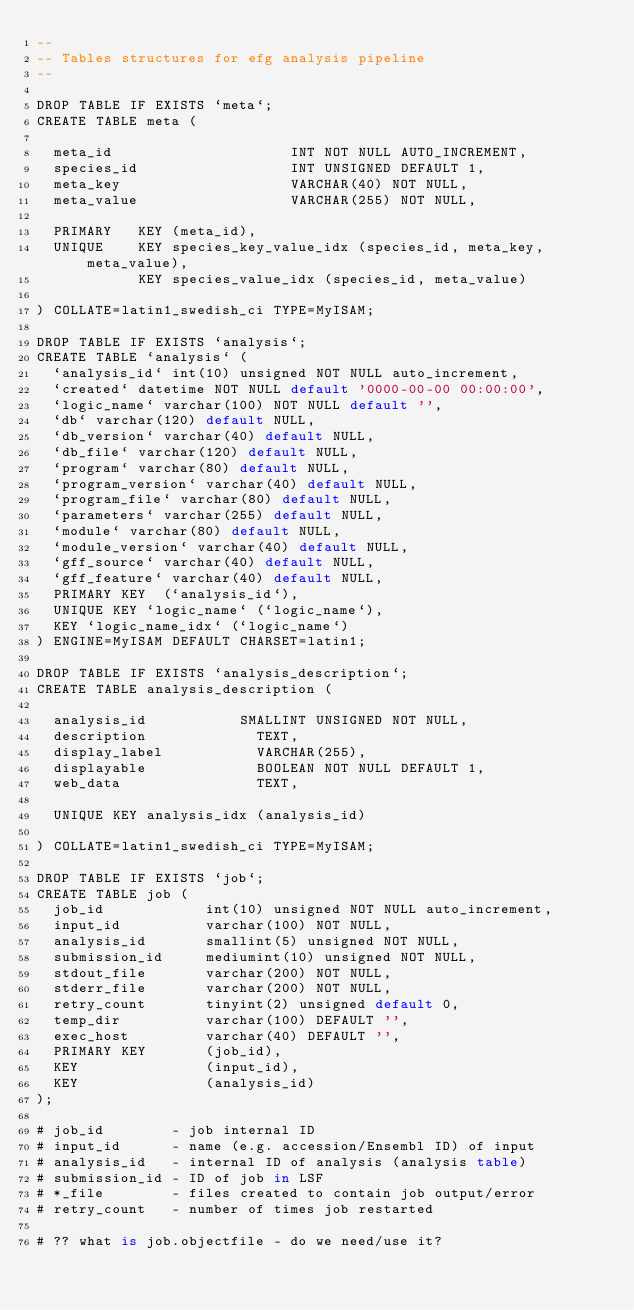<code> <loc_0><loc_0><loc_500><loc_500><_SQL_>--
-- Tables structures for efg analysis pipeline
--

DROP TABLE IF EXISTS `meta`;
CREATE TABLE meta (

  meta_id                     INT NOT NULL AUTO_INCREMENT,
  species_id                  INT UNSIGNED DEFAULT 1,
  meta_key                    VARCHAR(40) NOT NULL,
  meta_value                  VARCHAR(255) NOT NULL,

  PRIMARY   KEY (meta_id),
  UNIQUE    KEY species_key_value_idx (species_id, meta_key, meta_value),
            KEY species_value_idx (species_id, meta_value)

) COLLATE=latin1_swedish_ci TYPE=MyISAM;

DROP TABLE IF EXISTS `analysis`;
CREATE TABLE `analysis` (
  `analysis_id` int(10) unsigned NOT NULL auto_increment,
  `created` datetime NOT NULL default '0000-00-00 00:00:00',
  `logic_name` varchar(100) NOT NULL default '',
  `db` varchar(120) default NULL,
  `db_version` varchar(40) default NULL,
  `db_file` varchar(120) default NULL,
  `program` varchar(80) default NULL,
  `program_version` varchar(40) default NULL,
  `program_file` varchar(80) default NULL,
  `parameters` varchar(255) default NULL,
  `module` varchar(80) default NULL,
  `module_version` varchar(40) default NULL,
  `gff_source` varchar(40) default NULL,
  `gff_feature` varchar(40) default NULL,
  PRIMARY KEY  (`analysis_id`),
  UNIQUE KEY `logic_name` (`logic_name`),
  KEY `logic_name_idx` (`logic_name`)
) ENGINE=MyISAM DEFAULT CHARSET=latin1;

DROP TABLE IF EXISTS `analysis_description`;
CREATE TABLE analysis_description (

  analysis_id	          SMALLINT UNSIGNED NOT NULL,
  description             TEXT,
  display_label           VARCHAR(255),
  displayable             BOOLEAN NOT NULL DEFAULT 1,
  web_data                TEXT,

  UNIQUE KEY analysis_idx (analysis_id)
  
) COLLATE=latin1_swedish_ci TYPE=MyISAM;

DROP TABLE IF EXISTS `job`;
CREATE TABLE job (
  job_id            int(10) unsigned NOT NULL auto_increment,
  input_id          varchar(100) NOT NULL,
  analysis_id       smallint(5) unsigned NOT NULL,
  submission_id     mediumint(10) unsigned NOT NULL,
  stdout_file       varchar(200) NOT NULL,
  stderr_file       varchar(200) NOT NULL,
  retry_count       tinyint(2) unsigned default 0,
  temp_dir          varchar(100) DEFAULT '',
  exec_host         varchar(40) DEFAULT '',       
  PRIMARY KEY       (job_id),
  KEY               (input_id),
  KEY               (analysis_id)
);

# job_id        - job internal ID
# input_id      - name (e.g. accession/Ensembl ID) of input
# analysis_id   - internal ID of analysis (analysis table)
# submission_id - ID of job in LSF
# *_file        - files created to contain job output/error
# retry_count   - number of times job restarted

# ?? what is job.objectfile - do we need/use it?


</code> 